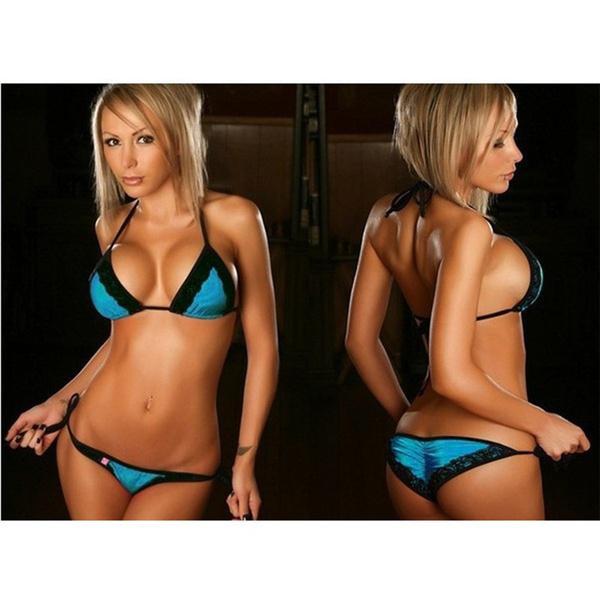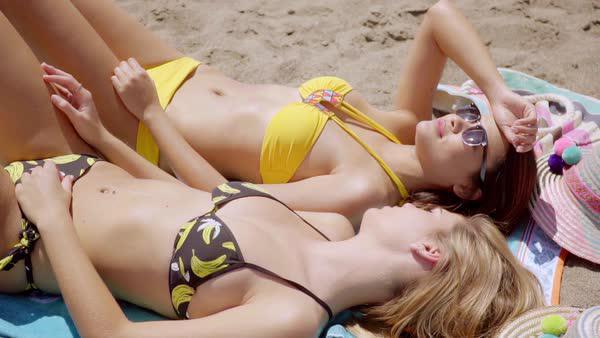The first image is the image on the left, the second image is the image on the right. Analyze the images presented: Is the assertion "Thr right image shows a blonde bikini model with at least one arm raised to her hair and her hip jutted to the right." valid? Answer yes or no. No. 